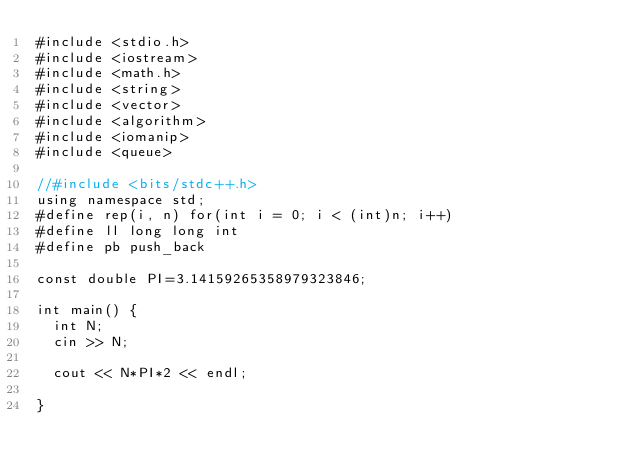Convert code to text. <code><loc_0><loc_0><loc_500><loc_500><_C++_>#include <stdio.h>
#include <iostream>
#include <math.h>
#include <string>
#include <vector>
#include <algorithm>
#include <iomanip>
#include <queue>

//#include <bits/stdc++.h>
using namespace std;
#define rep(i, n) for(int i = 0; i < (int)n; i++)
#define ll long long int
#define pb push_back

const double PI=3.14159265358979323846;

int main() {
  int N;
  cin >> N;
  
  cout << N*PI*2 << endl;

}
</code> 